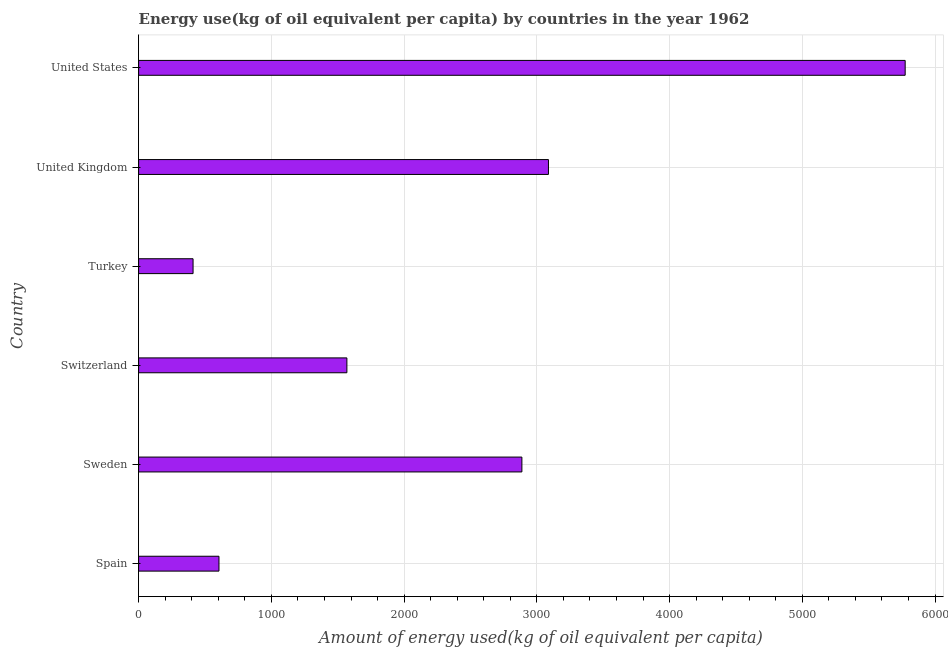Does the graph contain grids?
Make the answer very short. Yes. What is the title of the graph?
Provide a short and direct response. Energy use(kg of oil equivalent per capita) by countries in the year 1962. What is the label or title of the X-axis?
Keep it short and to the point. Amount of energy used(kg of oil equivalent per capita). What is the label or title of the Y-axis?
Offer a terse response. Country. What is the amount of energy used in Turkey?
Your response must be concise. 410.02. Across all countries, what is the maximum amount of energy used?
Provide a succinct answer. 5774.59. Across all countries, what is the minimum amount of energy used?
Offer a very short reply. 410.02. What is the sum of the amount of energy used?
Provide a succinct answer. 1.43e+04. What is the difference between the amount of energy used in Sweden and United Kingdom?
Your answer should be very brief. -200.11. What is the average amount of energy used per country?
Offer a terse response. 2388.89. What is the median amount of energy used?
Your response must be concise. 2228.07. In how many countries, is the amount of energy used greater than 3200 kg?
Your response must be concise. 1. Is the amount of energy used in Spain less than that in Turkey?
Offer a very short reply. No. Is the difference between the amount of energy used in Spain and United Kingdom greater than the difference between any two countries?
Your answer should be very brief. No. What is the difference between the highest and the second highest amount of energy used?
Offer a terse response. 2687.24. Is the sum of the amount of energy used in Spain and Sweden greater than the maximum amount of energy used across all countries?
Give a very brief answer. No. What is the difference between the highest and the lowest amount of energy used?
Offer a very short reply. 5364.56. Are all the bars in the graph horizontal?
Provide a short and direct response. Yes. How many countries are there in the graph?
Give a very brief answer. 6. What is the difference between two consecutive major ticks on the X-axis?
Ensure brevity in your answer.  1000. Are the values on the major ticks of X-axis written in scientific E-notation?
Offer a terse response. No. What is the Amount of energy used(kg of oil equivalent per capita) in Spain?
Provide a short and direct response. 605.22. What is the Amount of energy used(kg of oil equivalent per capita) in Sweden?
Offer a very short reply. 2887.24. What is the Amount of energy used(kg of oil equivalent per capita) in Switzerland?
Offer a terse response. 1568.91. What is the Amount of energy used(kg of oil equivalent per capita) of Turkey?
Offer a very short reply. 410.02. What is the Amount of energy used(kg of oil equivalent per capita) of United Kingdom?
Offer a very short reply. 3087.34. What is the Amount of energy used(kg of oil equivalent per capita) of United States?
Offer a terse response. 5774.59. What is the difference between the Amount of energy used(kg of oil equivalent per capita) in Spain and Sweden?
Offer a very short reply. -2282.01. What is the difference between the Amount of energy used(kg of oil equivalent per capita) in Spain and Switzerland?
Give a very brief answer. -963.69. What is the difference between the Amount of energy used(kg of oil equivalent per capita) in Spain and Turkey?
Your answer should be compact. 195.2. What is the difference between the Amount of energy used(kg of oil equivalent per capita) in Spain and United Kingdom?
Give a very brief answer. -2482.12. What is the difference between the Amount of energy used(kg of oil equivalent per capita) in Spain and United States?
Offer a terse response. -5169.36. What is the difference between the Amount of energy used(kg of oil equivalent per capita) in Sweden and Switzerland?
Give a very brief answer. 1318.33. What is the difference between the Amount of energy used(kg of oil equivalent per capita) in Sweden and Turkey?
Provide a short and direct response. 2477.21. What is the difference between the Amount of energy used(kg of oil equivalent per capita) in Sweden and United Kingdom?
Offer a terse response. -200.11. What is the difference between the Amount of energy used(kg of oil equivalent per capita) in Sweden and United States?
Provide a short and direct response. -2887.35. What is the difference between the Amount of energy used(kg of oil equivalent per capita) in Switzerland and Turkey?
Offer a terse response. 1158.89. What is the difference between the Amount of energy used(kg of oil equivalent per capita) in Switzerland and United Kingdom?
Your answer should be very brief. -1518.43. What is the difference between the Amount of energy used(kg of oil equivalent per capita) in Switzerland and United States?
Keep it short and to the point. -4205.68. What is the difference between the Amount of energy used(kg of oil equivalent per capita) in Turkey and United Kingdom?
Offer a terse response. -2677.32. What is the difference between the Amount of energy used(kg of oil equivalent per capita) in Turkey and United States?
Offer a very short reply. -5364.56. What is the difference between the Amount of energy used(kg of oil equivalent per capita) in United Kingdom and United States?
Your response must be concise. -2687.24. What is the ratio of the Amount of energy used(kg of oil equivalent per capita) in Spain to that in Sweden?
Your answer should be very brief. 0.21. What is the ratio of the Amount of energy used(kg of oil equivalent per capita) in Spain to that in Switzerland?
Provide a short and direct response. 0.39. What is the ratio of the Amount of energy used(kg of oil equivalent per capita) in Spain to that in Turkey?
Ensure brevity in your answer.  1.48. What is the ratio of the Amount of energy used(kg of oil equivalent per capita) in Spain to that in United Kingdom?
Give a very brief answer. 0.2. What is the ratio of the Amount of energy used(kg of oil equivalent per capita) in Spain to that in United States?
Give a very brief answer. 0.1. What is the ratio of the Amount of energy used(kg of oil equivalent per capita) in Sweden to that in Switzerland?
Provide a short and direct response. 1.84. What is the ratio of the Amount of energy used(kg of oil equivalent per capita) in Sweden to that in Turkey?
Ensure brevity in your answer.  7.04. What is the ratio of the Amount of energy used(kg of oil equivalent per capita) in Sweden to that in United Kingdom?
Your answer should be compact. 0.94. What is the ratio of the Amount of energy used(kg of oil equivalent per capita) in Sweden to that in United States?
Keep it short and to the point. 0.5. What is the ratio of the Amount of energy used(kg of oil equivalent per capita) in Switzerland to that in Turkey?
Offer a very short reply. 3.83. What is the ratio of the Amount of energy used(kg of oil equivalent per capita) in Switzerland to that in United Kingdom?
Keep it short and to the point. 0.51. What is the ratio of the Amount of energy used(kg of oil equivalent per capita) in Switzerland to that in United States?
Your answer should be compact. 0.27. What is the ratio of the Amount of energy used(kg of oil equivalent per capita) in Turkey to that in United Kingdom?
Your answer should be compact. 0.13. What is the ratio of the Amount of energy used(kg of oil equivalent per capita) in Turkey to that in United States?
Make the answer very short. 0.07. What is the ratio of the Amount of energy used(kg of oil equivalent per capita) in United Kingdom to that in United States?
Keep it short and to the point. 0.54. 